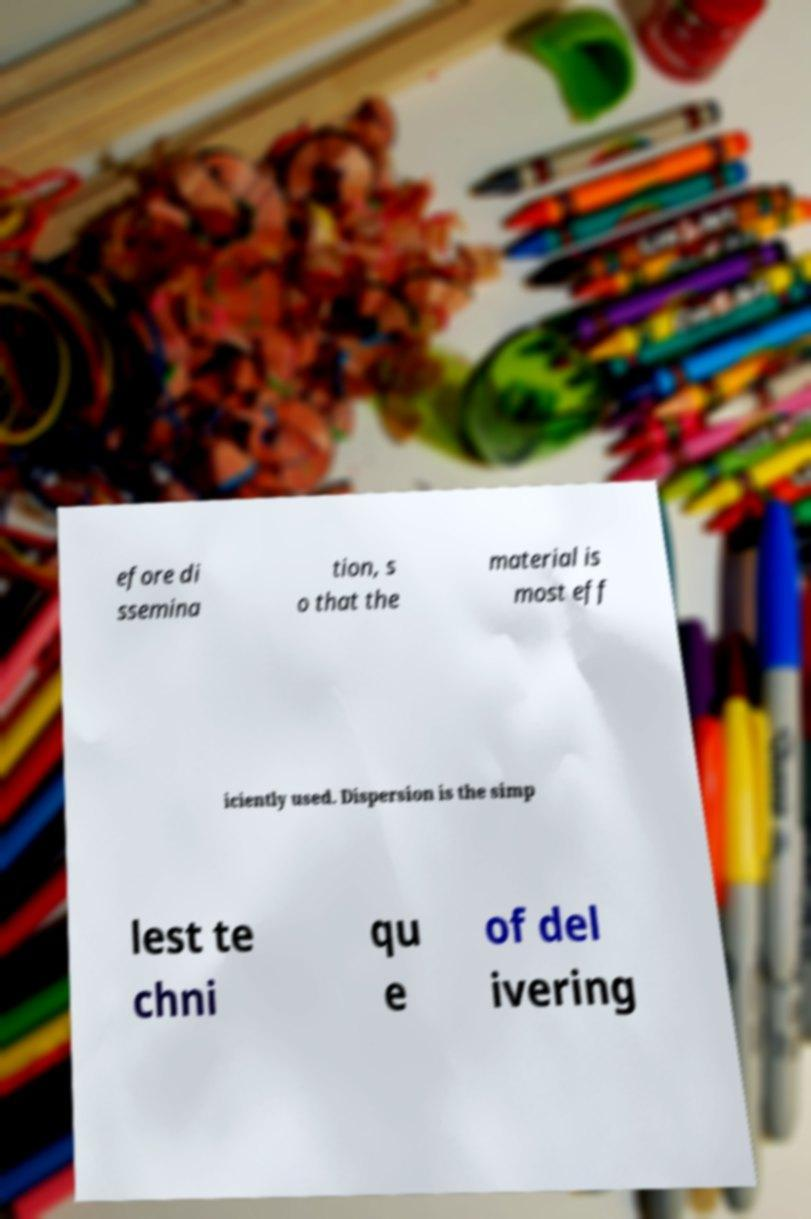Can you accurately transcribe the text from the provided image for me? efore di ssemina tion, s o that the material is most eff iciently used. Dispersion is the simp lest te chni qu e of del ivering 